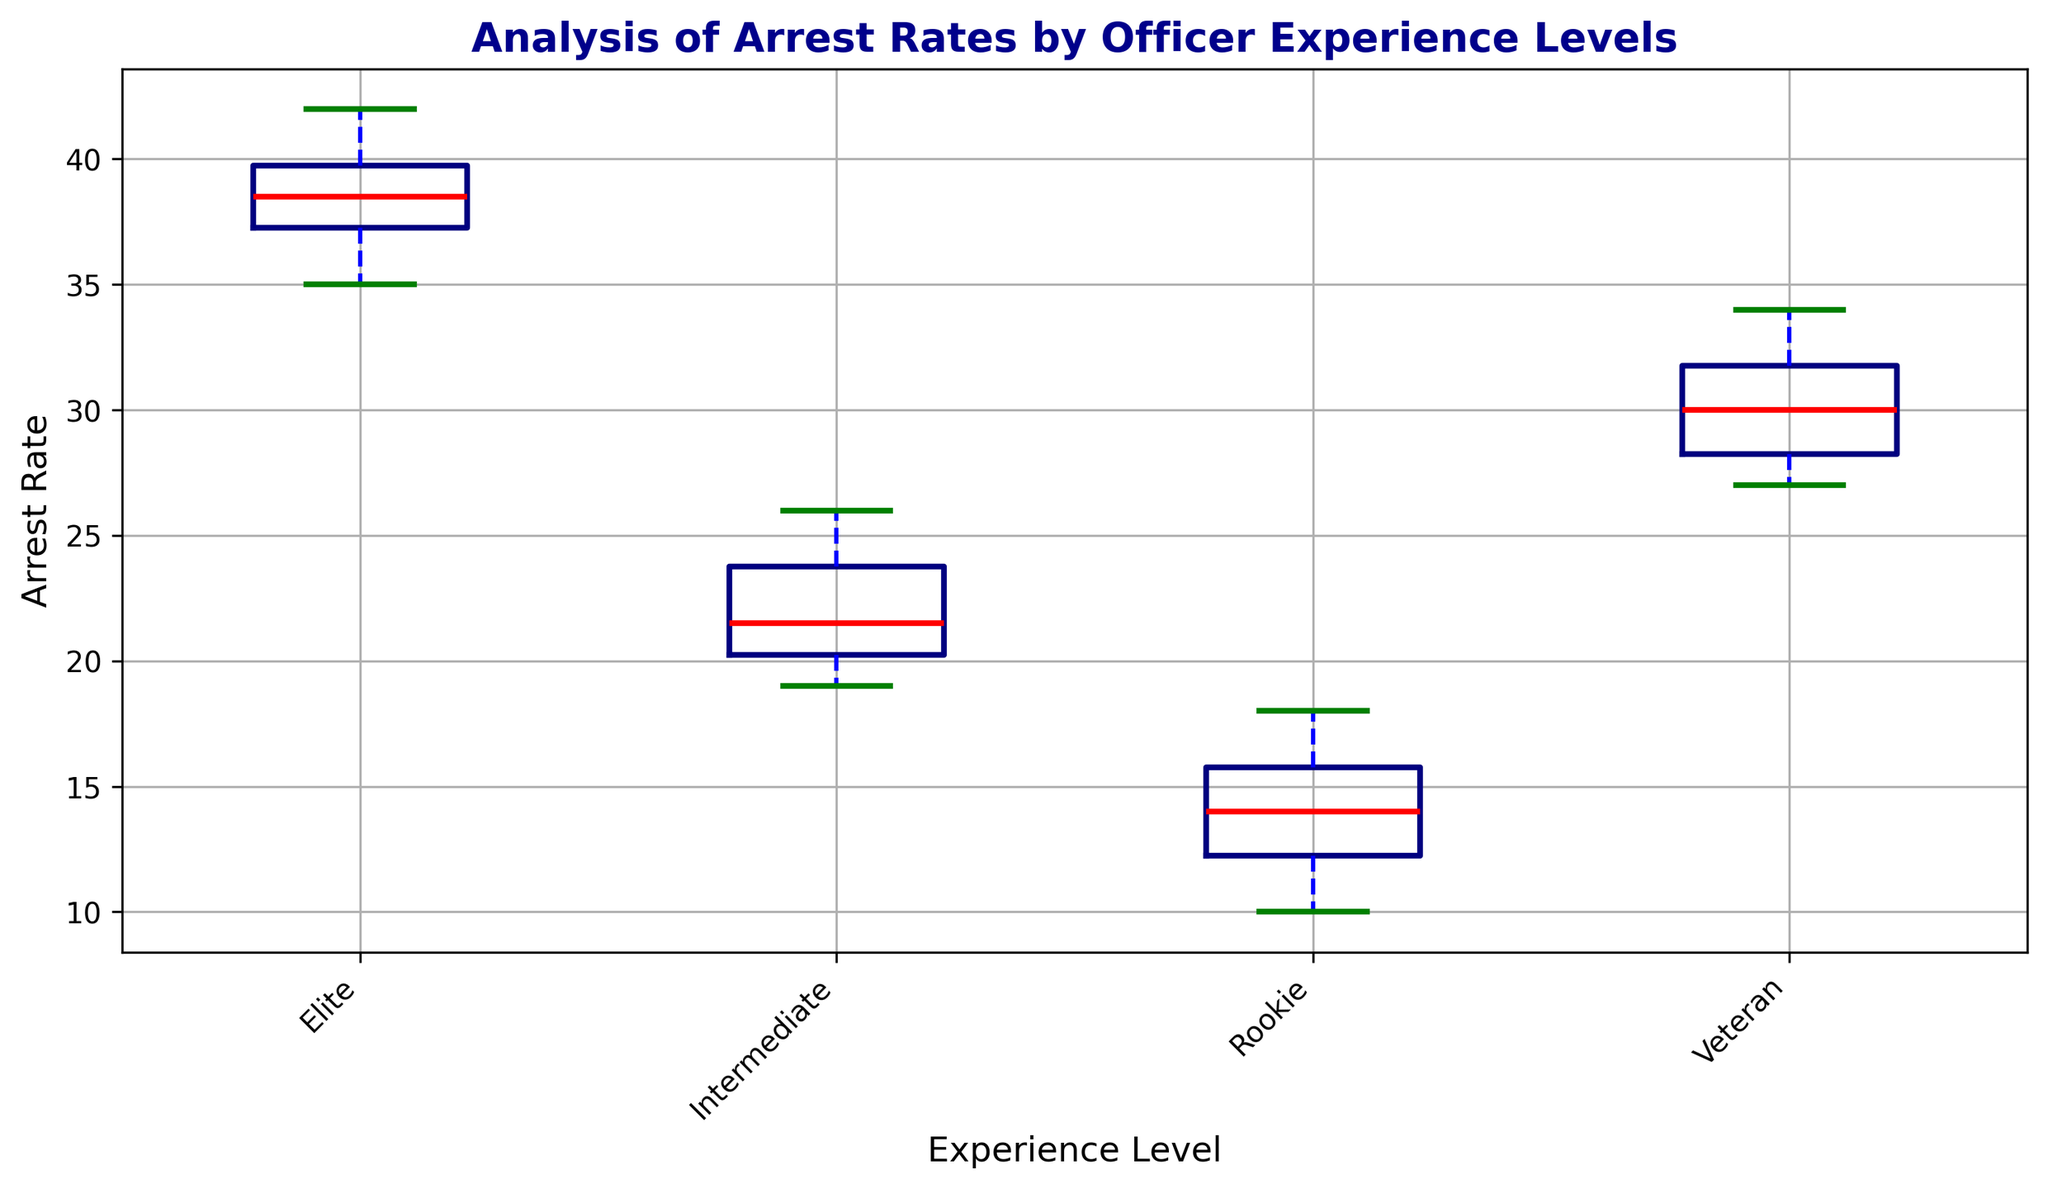What's the median arrest rate for Intermediate officers? The median is the middle value when all data points are ordered. For Intermediate officers, the sorted arrest rates are [19, 20, 20, 21, 21, 22, 23, 24, 25, 26]. The middle values are 21 and 22, so the median is (21 + 22) / 2 = 21.5
Answer: 21.5 Which experience level has the highest median arrest rate? Look at the positions of the median lines (colored in red) in each box plot. The median for Elite officers is the highest.
Answer: Elite What is the range of arrest rates for Rookie officers? The range is calculated by subtracting the minimum value from the maximum value. For Rookie officers, the arrest rates go from 10 to 18, so the range is 18 - 10 = 8
Answer: 8 How does the interquartile range (IQR) for Veterans compare to Rookies? The IQR can be estimated by the length of the boxes. Visually, the box for Veterans is shorter than that for Rookies, indicating a smaller IQR for Veterans.
Answer: Smaller Which experience level has the widest distribution of arrest rates? The widest distribution corresponds to the longest box plot whiskers. Checking visually, the Elite officers’ box plot has the longest whiskers.
Answer: Elite Are there any outliers in the arrest rates? Outliers would generally be marked with points outside the whiskers. In this case, none of the box plots appear to show points outside the whiskers, indicating no outliers.
Answer: No What is the difference between the median arrest rates of Rookie and Veteran officers? The median arrest rates can be read from the red lines: approximately 14 for Rookie and 30 for Veteran. The difference is therefore 30 - 14 = 16
Answer: 16 How do the median arrest rates for Intermediate and Veteran officers compare? From the box plots, the median for Intermediate is around 21.5 and for Veterans is 30. Thus, the median arrest rate for Veterans is higher.
Answer: Veterans higher 